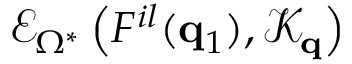<formula> <loc_0><loc_0><loc_500><loc_500>\mathcal { E } _ { \Omega ^ { * } } \left ( F ^ { i l } ( q _ { 1 } ) , \mathcal { K } _ { q } \right )</formula> 